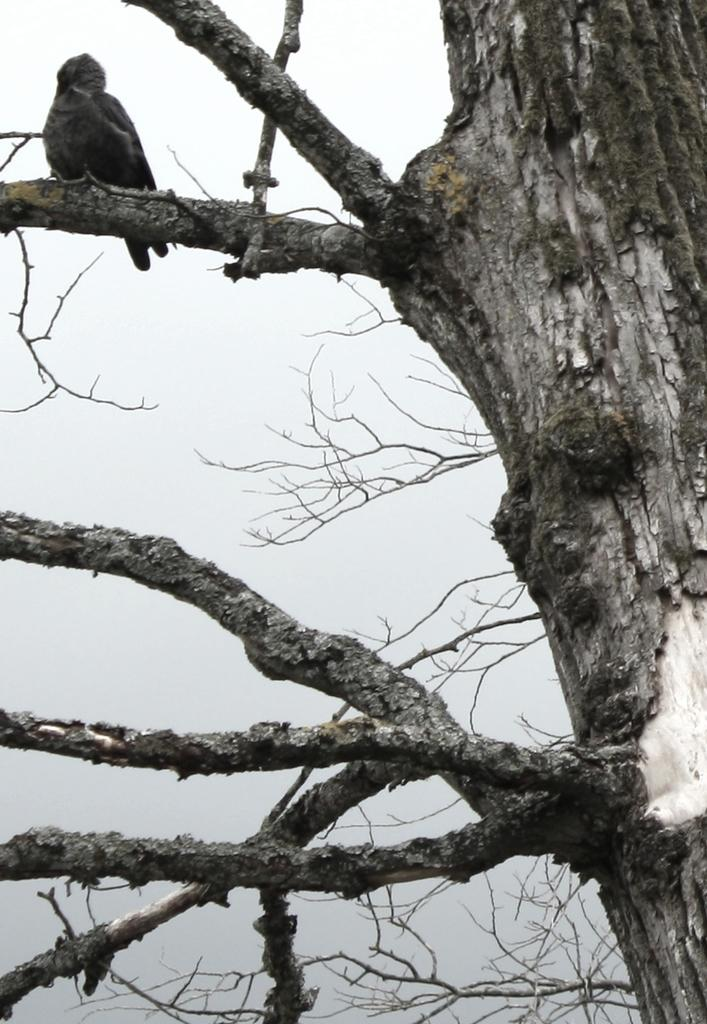What is the condition of the tree in the image? The tree in the image is dry. Is there any wildlife present in the image? Yes, a bird is sitting on the dry tree. What can be seen in the sky in the image? The sky is clear and visible at the top of the image. What type of chicken can be seen walking on the sidewalk in the image? There is no chicken or sidewalk present in the image. 